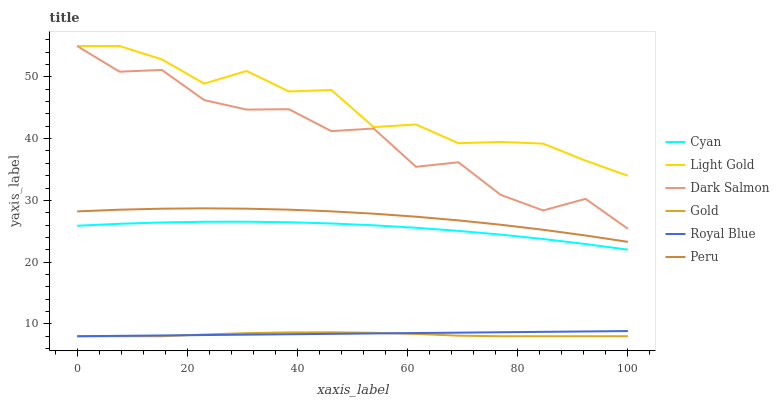Does Gold have the minimum area under the curve?
Answer yes or no. Yes. Does Light Gold have the maximum area under the curve?
Answer yes or no. Yes. Does Dark Salmon have the minimum area under the curve?
Answer yes or no. No. Does Dark Salmon have the maximum area under the curve?
Answer yes or no. No. Is Royal Blue the smoothest?
Answer yes or no. Yes. Is Dark Salmon the roughest?
Answer yes or no. Yes. Is Dark Salmon the smoothest?
Answer yes or no. No. Is Royal Blue the roughest?
Answer yes or no. No. Does Dark Salmon have the lowest value?
Answer yes or no. No. Does Royal Blue have the highest value?
Answer yes or no. No. Is Peru less than Dark Salmon?
Answer yes or no. Yes. Is Light Gold greater than Gold?
Answer yes or no. Yes. Does Peru intersect Dark Salmon?
Answer yes or no. No. 